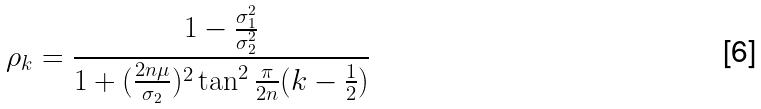<formula> <loc_0><loc_0><loc_500><loc_500>\rho _ { k } = \frac { 1 - \frac { \sigma _ { 1 } ^ { 2 } } { \sigma _ { 2 } ^ { 2 } } } { 1 + ( \frac { 2 n \mu } { \sigma _ { 2 } } ) ^ { 2 } \tan ^ { 2 } \frac { \pi } { 2 n } ( k - \frac { 1 } { 2 } ) }</formula> 